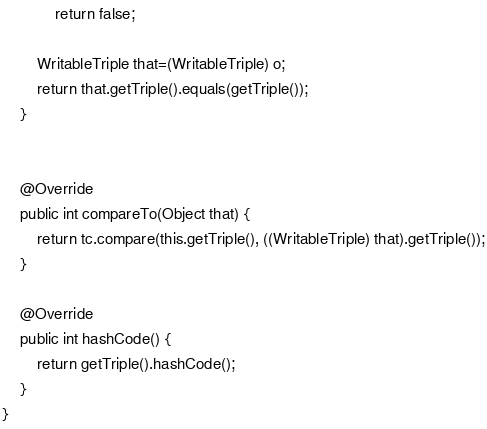<code> <loc_0><loc_0><loc_500><loc_500><_Java_>            return false;
        
        WritableTriple that=(WritableTriple) o;
        return that.getTriple().equals(getTriple());
    }


    @Override
    public int compareTo(Object that) {
        return tc.compare(this.getTriple(), ((WritableTriple) that).getTriple());
    }

    @Override
    public int hashCode() {
        return getTriple().hashCode();
    }
}
</code> 